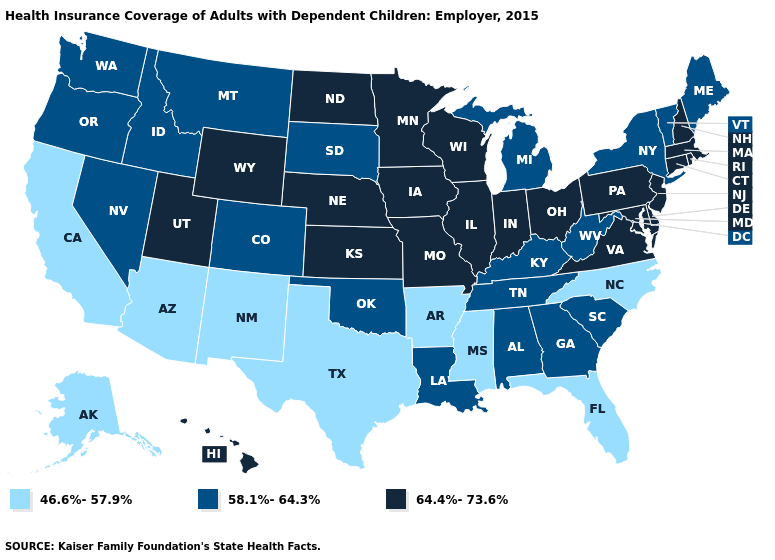Does New Hampshire have the lowest value in the Northeast?
Answer briefly. No. Does the first symbol in the legend represent the smallest category?
Write a very short answer. Yes. Which states have the lowest value in the USA?
Write a very short answer. Alaska, Arizona, Arkansas, California, Florida, Mississippi, New Mexico, North Carolina, Texas. Does Massachusetts have the highest value in the Northeast?
Write a very short answer. Yes. What is the value of New Hampshire?
Write a very short answer. 64.4%-73.6%. Is the legend a continuous bar?
Write a very short answer. No. Is the legend a continuous bar?
Concise answer only. No. Which states hav the highest value in the MidWest?
Give a very brief answer. Illinois, Indiana, Iowa, Kansas, Minnesota, Missouri, Nebraska, North Dakota, Ohio, Wisconsin. What is the lowest value in the MidWest?
Answer briefly. 58.1%-64.3%. What is the lowest value in the MidWest?
Give a very brief answer. 58.1%-64.3%. Name the states that have a value in the range 46.6%-57.9%?
Give a very brief answer. Alaska, Arizona, Arkansas, California, Florida, Mississippi, New Mexico, North Carolina, Texas. Name the states that have a value in the range 46.6%-57.9%?
Keep it brief. Alaska, Arizona, Arkansas, California, Florida, Mississippi, New Mexico, North Carolina, Texas. Is the legend a continuous bar?
Concise answer only. No. What is the value of Georgia?
Write a very short answer. 58.1%-64.3%. What is the value of Maine?
Answer briefly. 58.1%-64.3%. 